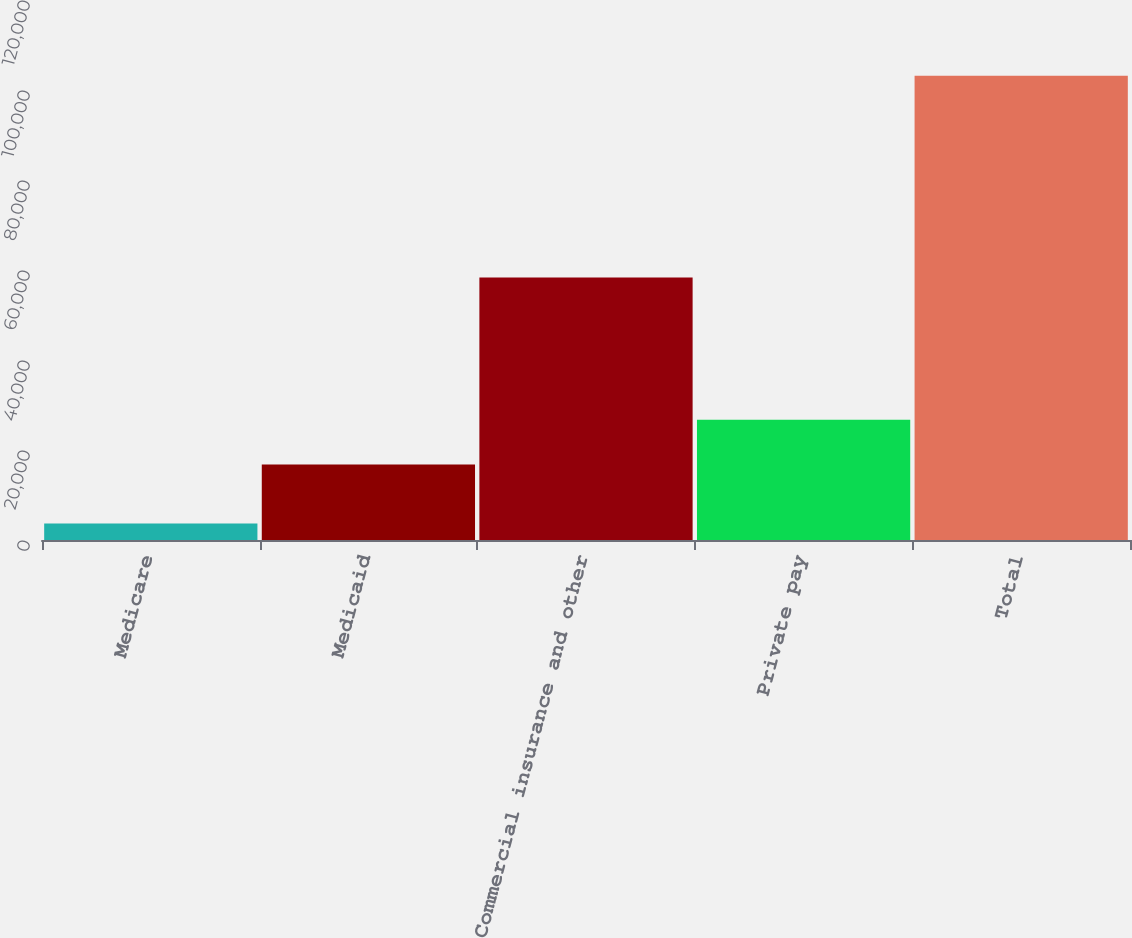Convert chart. <chart><loc_0><loc_0><loc_500><loc_500><bar_chart><fcel>Medicare<fcel>Medicaid<fcel>Commercial insurance and other<fcel>Private pay<fcel>Total<nl><fcel>3656<fcel>16769<fcel>58332<fcel>26720<fcel>103166<nl></chart> 